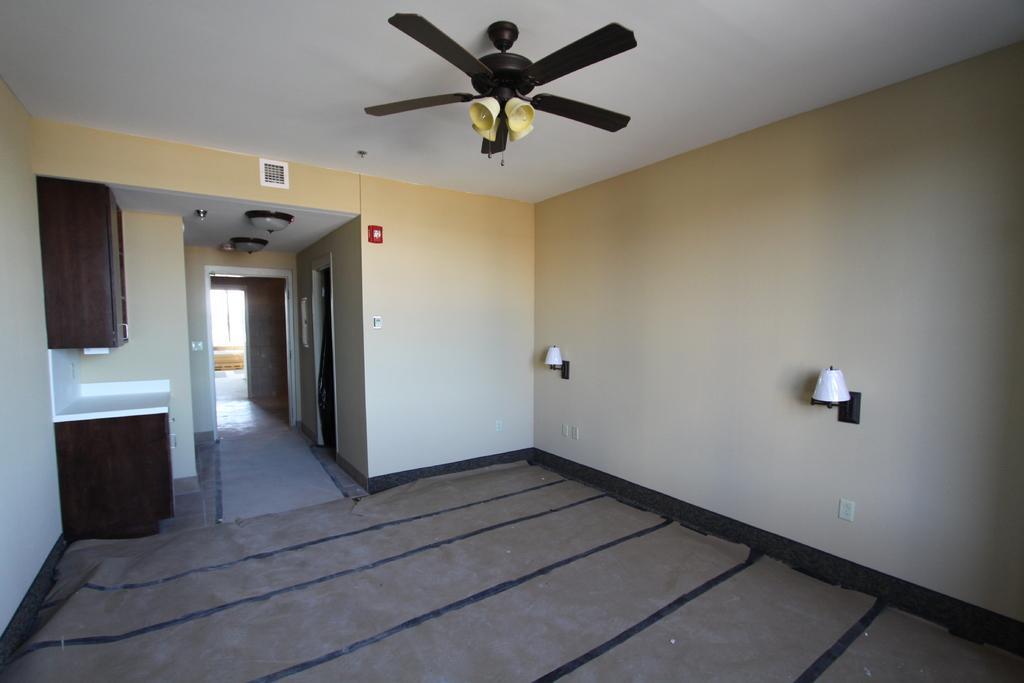Can you describe this image briefly? In this image I can see the inner part of the building. I can see few lights, cupboard, table, wall and few objects. At the top I can see the light ceiling fan. 